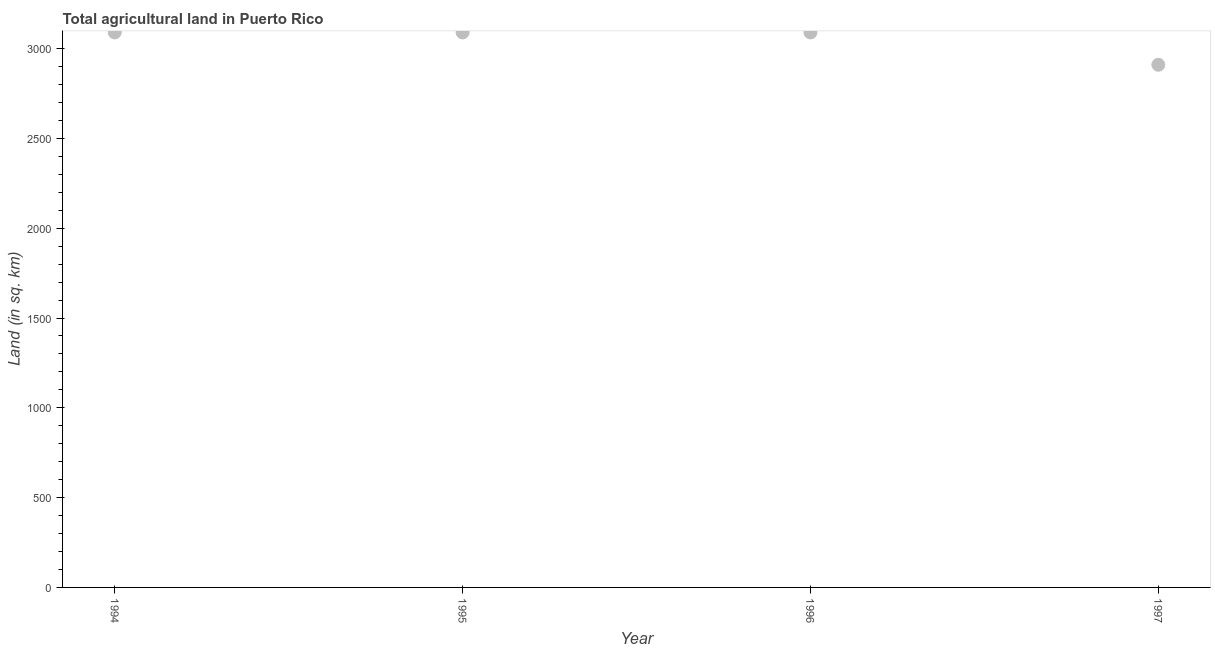What is the agricultural land in 1997?
Ensure brevity in your answer.  2910. Across all years, what is the maximum agricultural land?
Give a very brief answer. 3090. Across all years, what is the minimum agricultural land?
Provide a succinct answer. 2910. What is the sum of the agricultural land?
Provide a short and direct response. 1.22e+04. What is the average agricultural land per year?
Keep it short and to the point. 3045. What is the median agricultural land?
Offer a very short reply. 3090. In how many years, is the agricultural land greater than 1200 sq. km?
Provide a succinct answer. 4. What is the ratio of the agricultural land in 1995 to that in 1996?
Give a very brief answer. 1. Is the sum of the agricultural land in 1996 and 1997 greater than the maximum agricultural land across all years?
Offer a very short reply. Yes. What is the difference between the highest and the lowest agricultural land?
Provide a succinct answer. 180. How many years are there in the graph?
Offer a terse response. 4. What is the difference between two consecutive major ticks on the Y-axis?
Your answer should be very brief. 500. Does the graph contain any zero values?
Your response must be concise. No. What is the title of the graph?
Provide a succinct answer. Total agricultural land in Puerto Rico. What is the label or title of the Y-axis?
Provide a succinct answer. Land (in sq. km). What is the Land (in sq. km) in 1994?
Make the answer very short. 3090. What is the Land (in sq. km) in 1995?
Keep it short and to the point. 3090. What is the Land (in sq. km) in 1996?
Your answer should be compact. 3090. What is the Land (in sq. km) in 1997?
Ensure brevity in your answer.  2910. What is the difference between the Land (in sq. km) in 1994 and 1995?
Offer a very short reply. 0. What is the difference between the Land (in sq. km) in 1994 and 1997?
Offer a very short reply. 180. What is the difference between the Land (in sq. km) in 1995 and 1997?
Provide a short and direct response. 180. What is the difference between the Land (in sq. km) in 1996 and 1997?
Give a very brief answer. 180. What is the ratio of the Land (in sq. km) in 1994 to that in 1995?
Offer a very short reply. 1. What is the ratio of the Land (in sq. km) in 1994 to that in 1997?
Your answer should be very brief. 1.06. What is the ratio of the Land (in sq. km) in 1995 to that in 1996?
Make the answer very short. 1. What is the ratio of the Land (in sq. km) in 1995 to that in 1997?
Your answer should be compact. 1.06. What is the ratio of the Land (in sq. km) in 1996 to that in 1997?
Give a very brief answer. 1.06. 